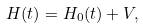<formula> <loc_0><loc_0><loc_500><loc_500>H ( t ) = H _ { 0 } ( t ) + V ,</formula> 